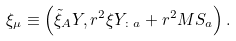Convert formula to latex. <formula><loc_0><loc_0><loc_500><loc_500>\xi _ { \mu } \equiv \left ( \tilde { \xi } _ { A } Y , r ^ { 2 } \xi Y _ { \colon a } + r ^ { 2 } M S _ { a } \right ) .</formula> 